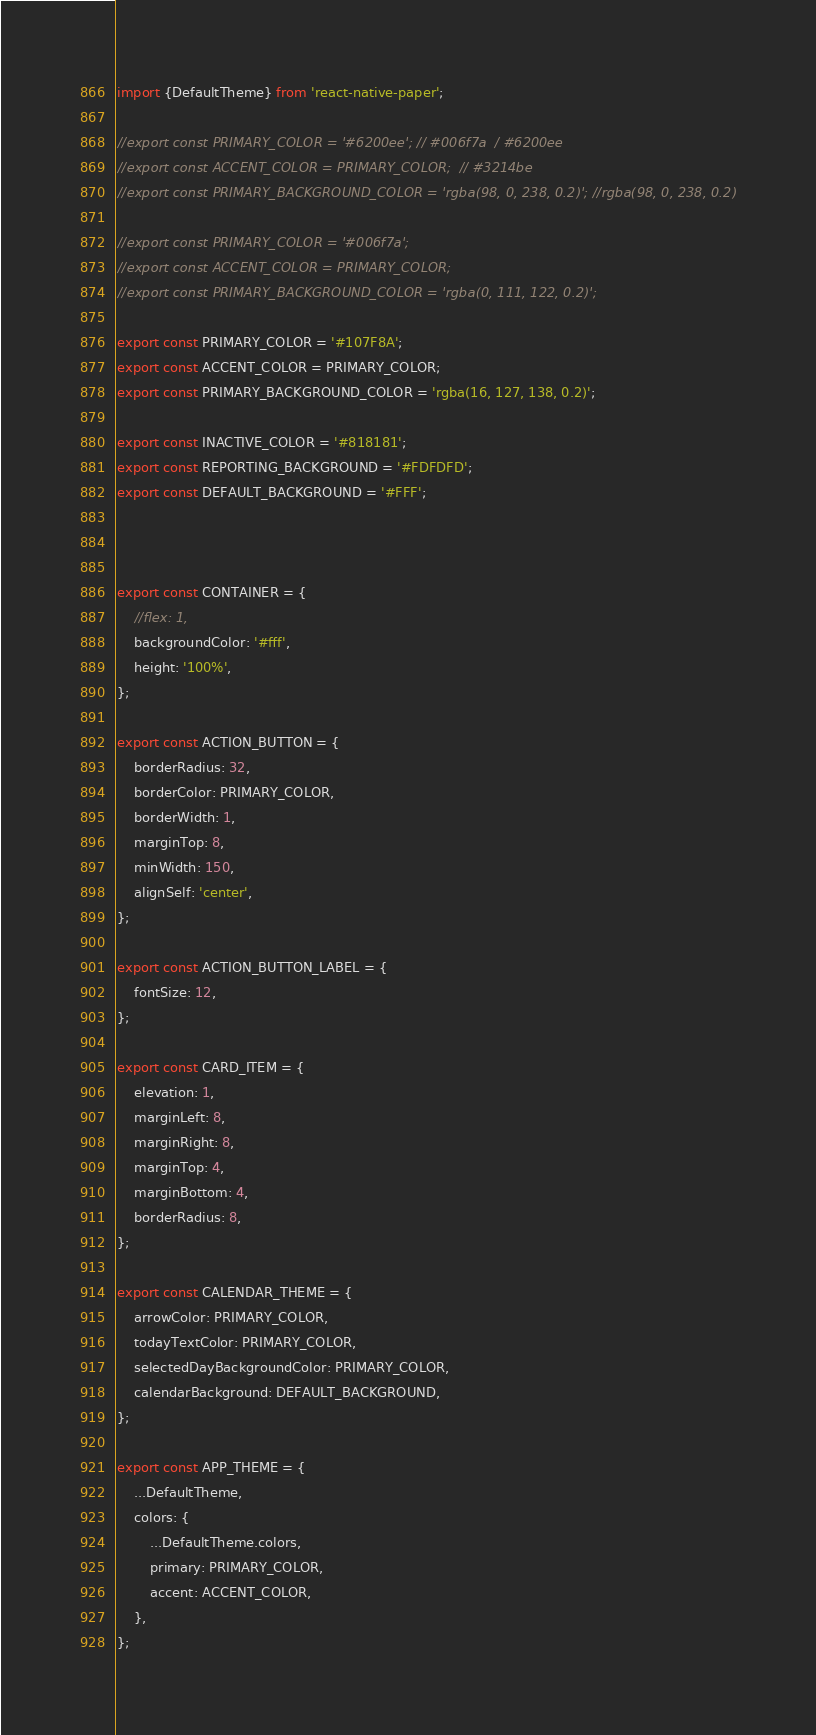Convert code to text. <code><loc_0><loc_0><loc_500><loc_500><_JavaScript_>import {DefaultTheme} from 'react-native-paper';

//export const PRIMARY_COLOR = '#6200ee'; // #006f7a  / #6200ee
//export const ACCENT_COLOR = PRIMARY_COLOR;  // #3214be
//export const PRIMARY_BACKGROUND_COLOR = 'rgba(98, 0, 238, 0.2)'; //rgba(98, 0, 238, 0.2)

//export const PRIMARY_COLOR = '#006f7a';
//export const ACCENT_COLOR = PRIMARY_COLOR;
//export const PRIMARY_BACKGROUND_COLOR = 'rgba(0, 111, 122, 0.2)';

export const PRIMARY_COLOR = '#107F8A';
export const ACCENT_COLOR = PRIMARY_COLOR;
export const PRIMARY_BACKGROUND_COLOR = 'rgba(16, 127, 138, 0.2)';

export const INACTIVE_COLOR = '#818181';
export const REPORTING_BACKGROUND = '#FDFDFD';
export const DEFAULT_BACKGROUND = '#FFF';



export const CONTAINER = {
    //flex: 1,
    backgroundColor: '#fff',
    height: '100%',
};

export const ACTION_BUTTON = {
    borderRadius: 32,
    borderColor: PRIMARY_COLOR,
    borderWidth: 1,
    marginTop: 8,
    minWidth: 150,
    alignSelf: 'center',
};

export const ACTION_BUTTON_LABEL = {
    fontSize: 12,
};

export const CARD_ITEM = {
    elevation: 1,
    marginLeft: 8,
    marginRight: 8,
    marginTop: 4,
    marginBottom: 4,
    borderRadius: 8,
};

export const CALENDAR_THEME = {
    arrowColor: PRIMARY_COLOR,
    todayTextColor: PRIMARY_COLOR,
    selectedDayBackgroundColor: PRIMARY_COLOR,
    calendarBackground: DEFAULT_BACKGROUND,
};

export const APP_THEME = {
    ...DefaultTheme,
    colors: {
        ...DefaultTheme.colors,
        primary: PRIMARY_COLOR,
        accent: ACCENT_COLOR,
    },
};
</code> 